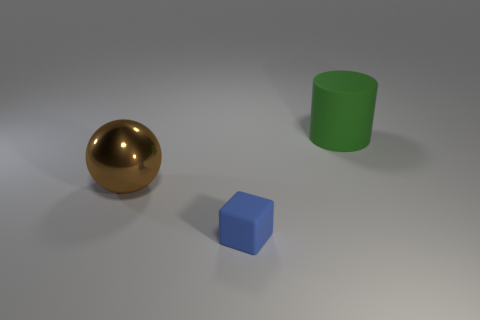Subtract all red cylinders. Subtract all cyan spheres. How many cylinders are left? 1 Add 1 big matte things. How many objects exist? 4 Subtract all blocks. How many objects are left? 2 Subtract all spheres. Subtract all tiny blue objects. How many objects are left? 1 Add 1 brown metal objects. How many brown metal objects are left? 2 Add 3 big brown balls. How many big brown balls exist? 4 Subtract 0 blue spheres. How many objects are left? 3 